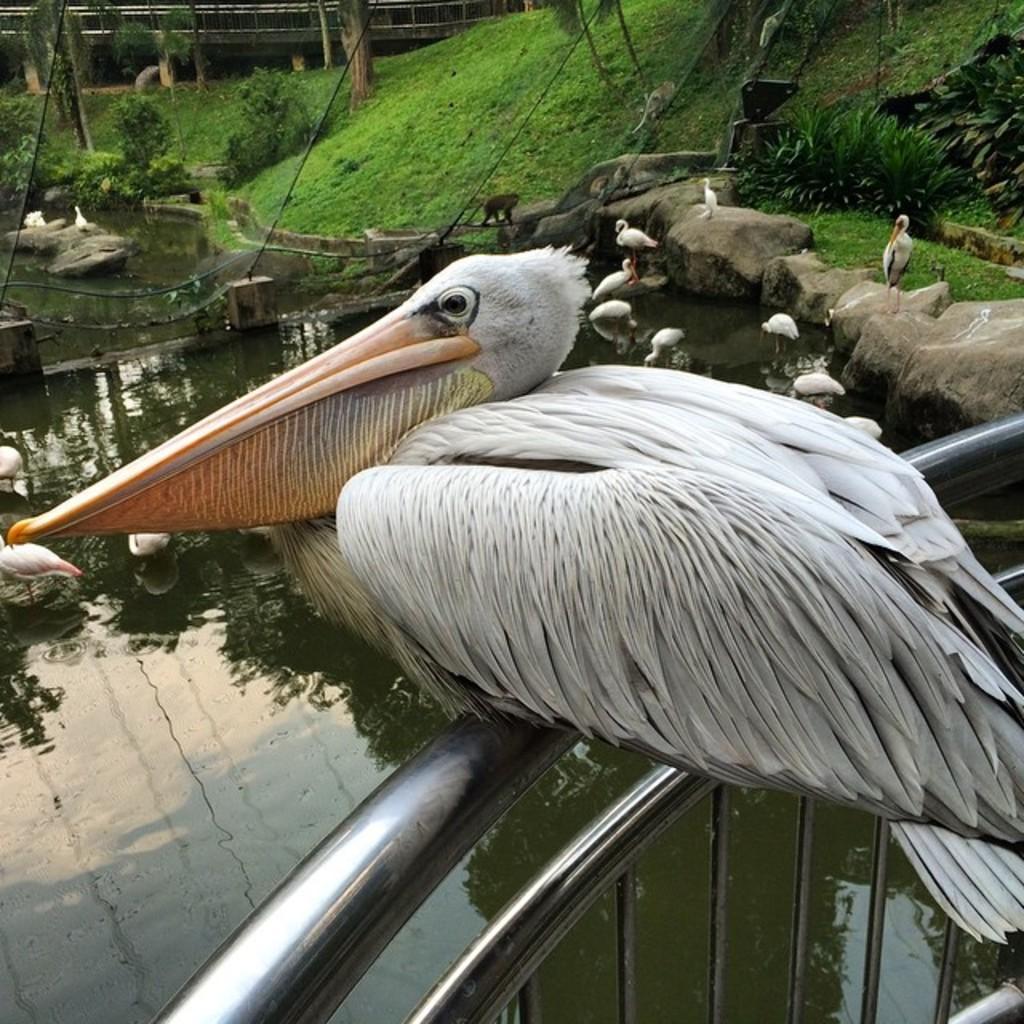Can you describe this image briefly? In this picture we can see a bird on a railing and in front of this bird we can see stones, water, birds, animals, grass, plants and some objects. 